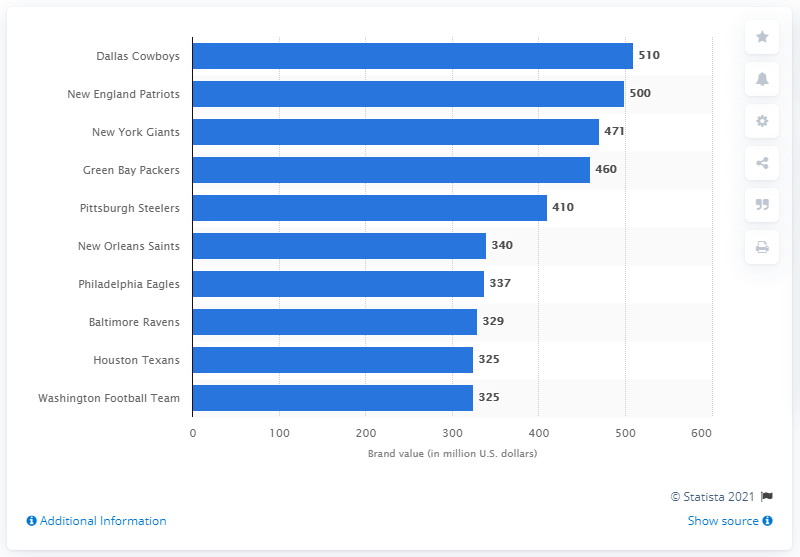Mention a couple of crucial points in this snapshot. The brand value of the New England Patriots in 2012 was estimated to be approximately 500 million dollars. 